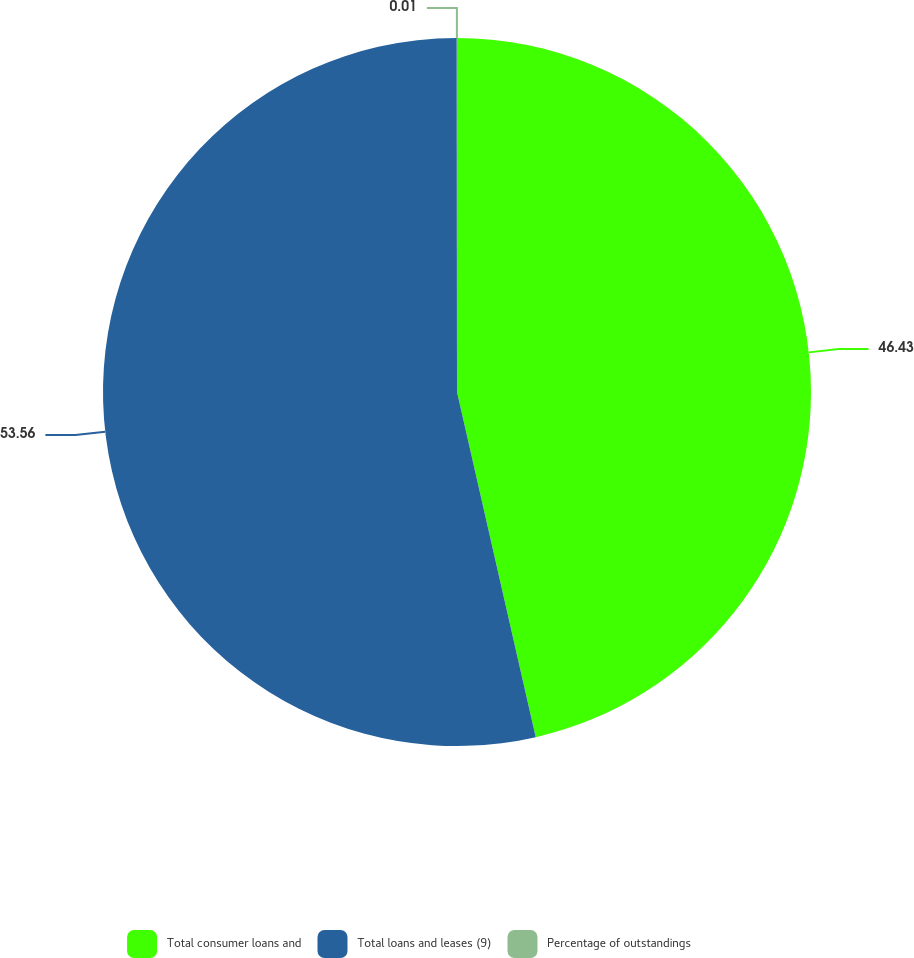Convert chart to OTSL. <chart><loc_0><loc_0><loc_500><loc_500><pie_chart><fcel>Total consumer loans and<fcel>Total loans and leases (9)<fcel>Percentage of outstandings<nl><fcel>46.43%<fcel>53.56%<fcel>0.01%<nl></chart> 